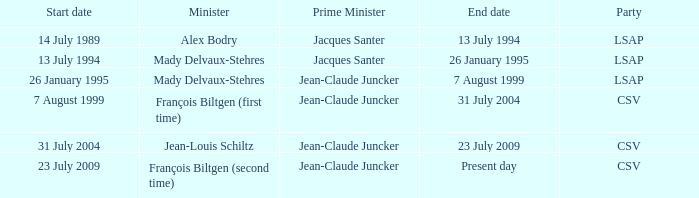I'm looking to parse the entire table for insights. Could you assist me with that? {'header': ['Start date', 'Minister', 'Prime Minister', 'End date', 'Party'], 'rows': [['14 July 1989', 'Alex Bodry', 'Jacques Santer', '13 July 1994', 'LSAP'], ['13 July 1994', 'Mady Delvaux-Stehres', 'Jacques Santer', '26 January 1995', 'LSAP'], ['26 January 1995', 'Mady Delvaux-Stehres', 'Jean-Claude Juncker', '7 August 1999', 'LSAP'], ['7 August 1999', 'François Biltgen (first time)', 'Jean-Claude Juncker', '31 July 2004', 'CSV'], ['31 July 2004', 'Jean-Louis Schiltz', 'Jean-Claude Juncker', '23 July 2009', 'CSV'], ['23 July 2009', 'François Biltgen (second time)', 'Jean-Claude Juncker', 'Present day', 'CSV']]} What was the end date when Alex Bodry was the minister? 13 July 1994. 